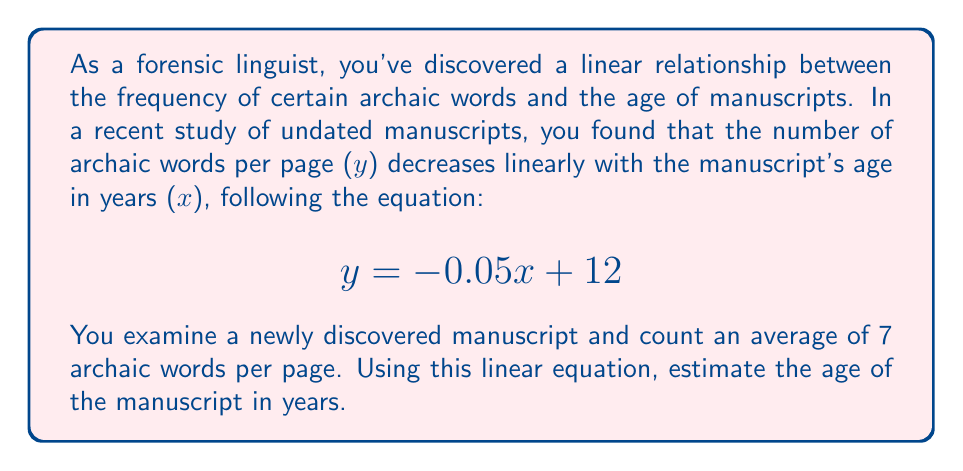Can you solve this math problem? To solve this problem, we'll use the given linear equation and the information about the newly discovered manuscript:

1. The linear equation: $y = -0.05x + 12$
   Where $y$ is the number of archaic words per page, and $x$ is the age of the manuscript in years.

2. For the new manuscript, we know that $y = 7$ (7 archaic words per page).

3. Substitute $y = 7$ into the equation:
   $7 = -0.05x + 12$

4. Solve for $x$:
   $7 - 12 = -0.05x$
   $-5 = -0.05x$

5. Divide both sides by -0.05:
   $\frac{-5}{-0.05} = x$
   $100 = x$

Therefore, the estimated age of the manuscript is 100 years.
Answer: 100 years 